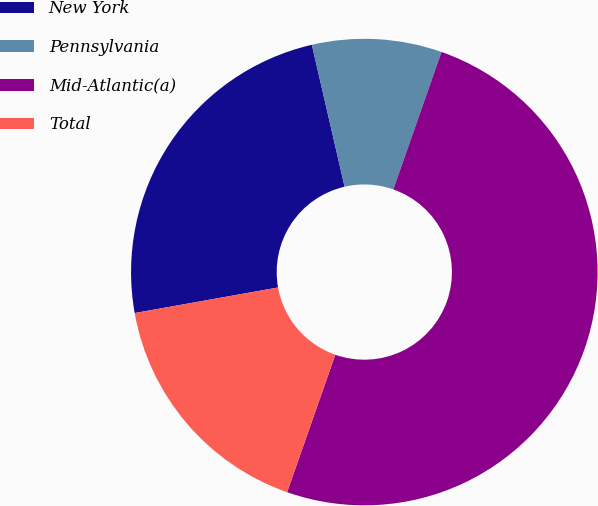<chart> <loc_0><loc_0><loc_500><loc_500><pie_chart><fcel>New York<fcel>Pennsylvania<fcel>Mid-Atlantic(a)<fcel>Total<nl><fcel>24.2%<fcel>8.98%<fcel>50.0%<fcel>16.82%<nl></chart> 